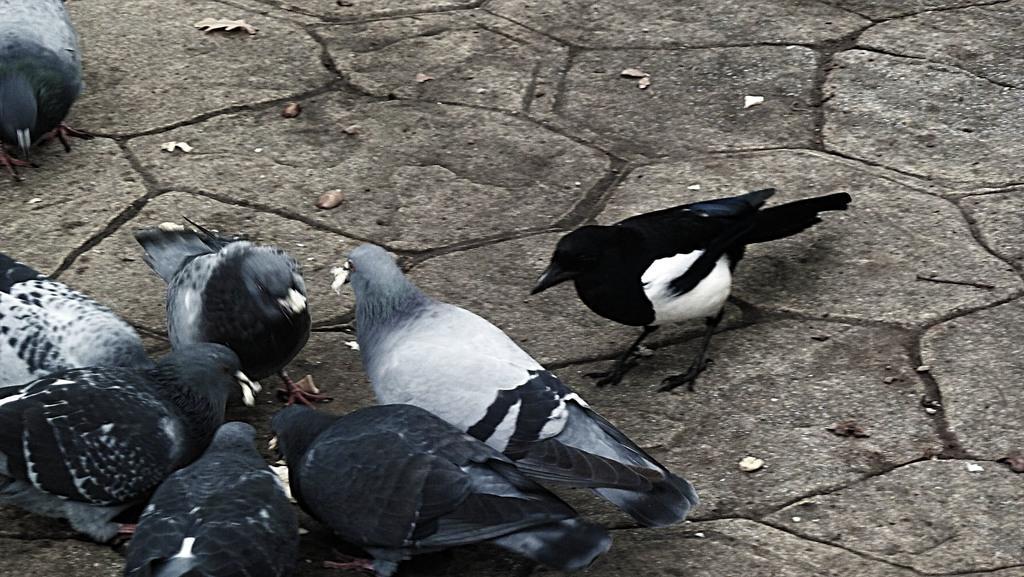Can you describe this image briefly? In the foreground of this picture, there are few pigeons and a black bird on the ground. 